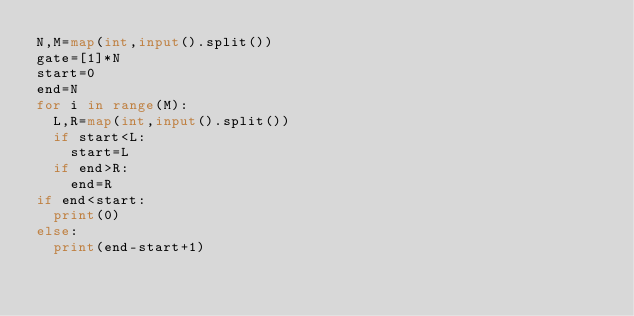Convert code to text. <code><loc_0><loc_0><loc_500><loc_500><_Python_>N,M=map(int,input().split())
gate=[1]*N
start=0
end=N
for i in range(M):
  L,R=map(int,input().split())
  if start<L:
    start=L
  if end>R:
    end=R
if end<start:
  print(0)
else:
  print(end-start+1)</code> 